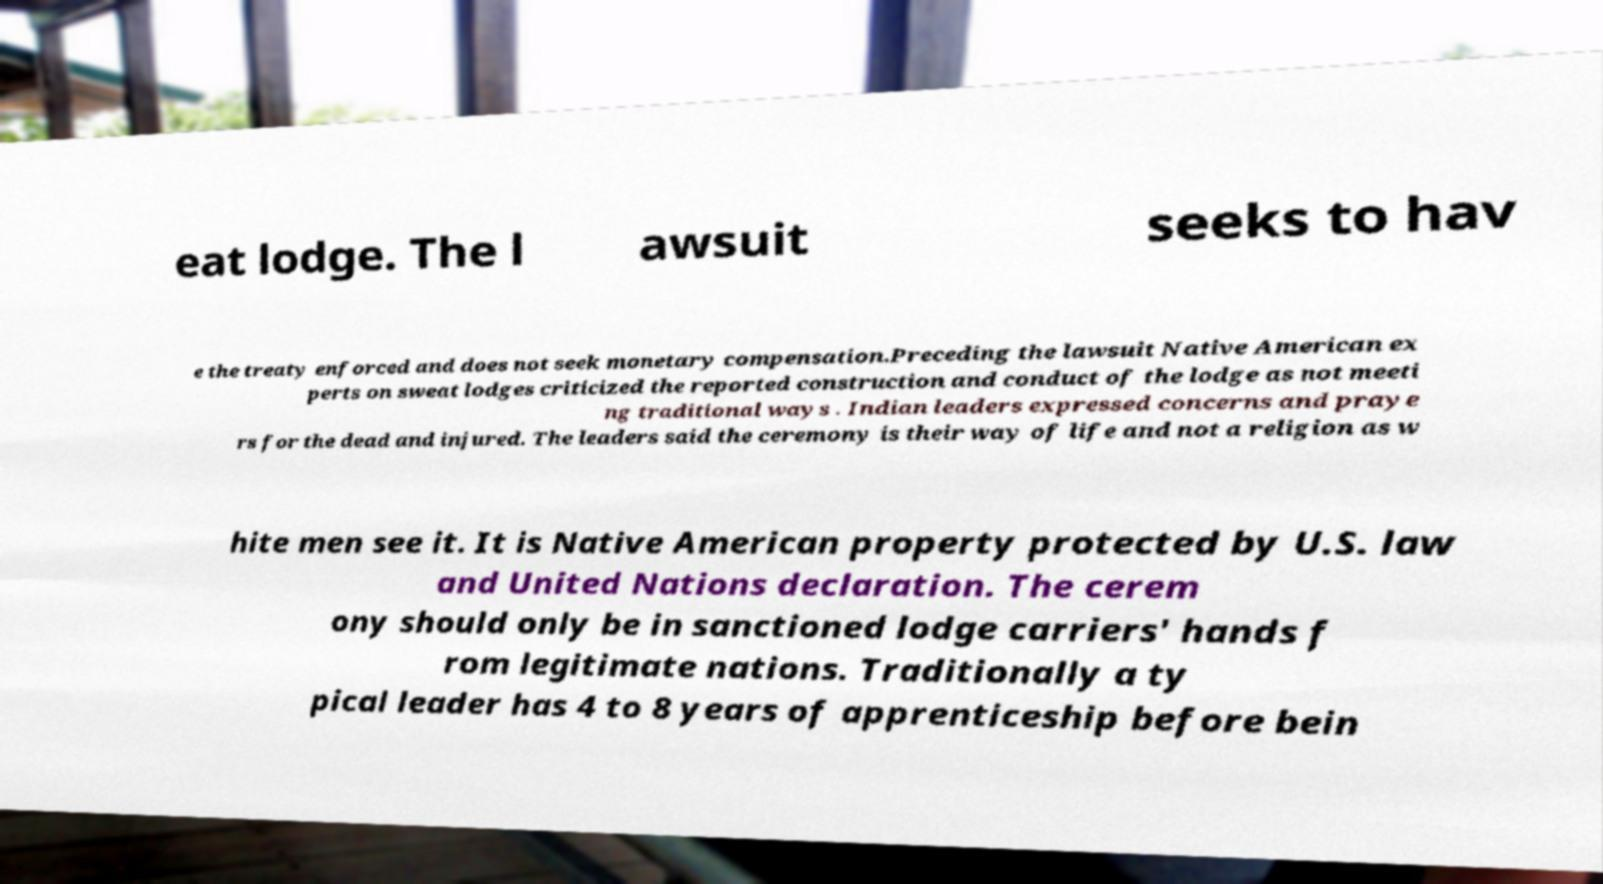Can you read and provide the text displayed in the image?This photo seems to have some interesting text. Can you extract and type it out for me? eat lodge. The l awsuit seeks to hav e the treaty enforced and does not seek monetary compensation.Preceding the lawsuit Native American ex perts on sweat lodges criticized the reported construction and conduct of the lodge as not meeti ng traditional ways . Indian leaders expressed concerns and praye rs for the dead and injured. The leaders said the ceremony is their way of life and not a religion as w hite men see it. It is Native American property protected by U.S. law and United Nations declaration. The cerem ony should only be in sanctioned lodge carriers' hands f rom legitimate nations. Traditionally a ty pical leader has 4 to 8 years of apprenticeship before bein 